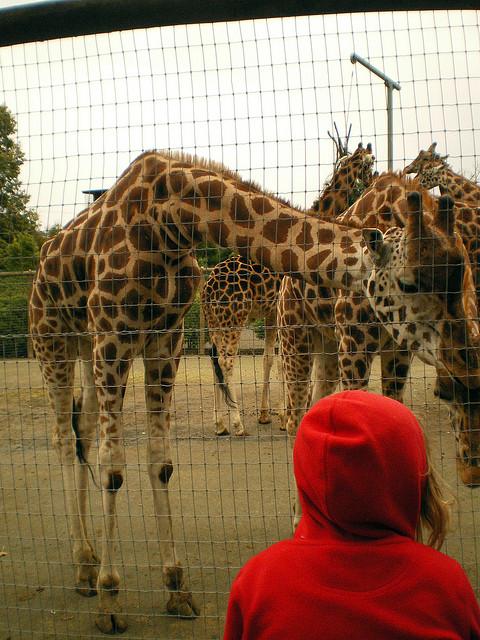What color is her sweatshirt?
Be succinct. Red. Is the person on the right wearing red?
Quick response, please. Yes. Do the giraffes have mane?
Keep it brief. Yes. 